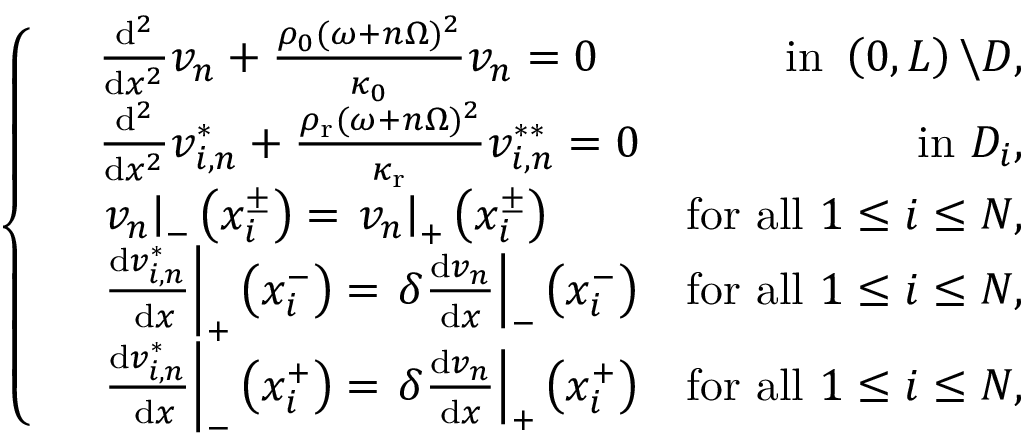<formula> <loc_0><loc_0><loc_500><loc_500>\left \{ \begin{array} { r l r } & { \frac { d ^ { 2 } } { d x ^ { 2 } } v _ { n } + \frac { \rho _ { 0 } ( \omega + n \Omega ) ^ { 2 } } { \kappa _ { 0 } } v _ { n } = 0 } & { i n \left ( 0 , L \right ) \ D , } \\ & { \frac { d ^ { 2 } } { d x ^ { 2 } } v _ { i , n } ^ { * } + \frac { \rho _ { r } ( \omega + n \Omega ) ^ { 2 } } { \kappa _ { r } } v _ { i , n } ^ { * * } = 0 } & { i n D _ { i } , } \\ & { v _ { n } \right | _ { - } \left ( x _ { i } ^ { \pm } \right ) = v _ { n } \right | _ { + } \left ( x _ { i } ^ { \pm } \right ) } & { f o r a l l 1 \leq i \leq N , } \\ & { \frac { d v _ { i , n } ^ { * } } { d x } \right | _ { + } \left ( x _ { i } ^ { - } \right ) = \delta \frac { d v _ { n } } { d x } \right | _ { - } \left ( x _ { i } ^ { - } \right ) } & { f o r a l l 1 \leq i \leq N , } \\ & { \frac { d v _ { i , n } ^ { * } } { d x } \right | _ { - } \left ( x _ { i } ^ { + } \right ) = \delta \frac { d v _ { n } } { d x } \right | _ { + } \left ( x _ { i } ^ { + } \right ) } & { f o r a l l 1 \leq i \leq N , } \end{array}</formula> 